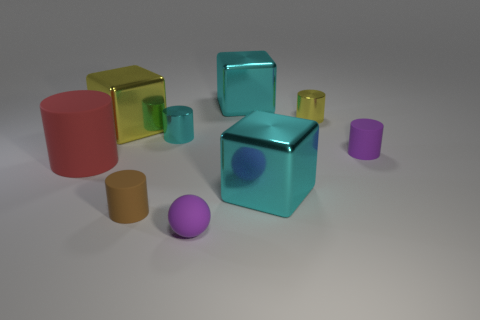Are the big yellow block and the tiny yellow cylinder made of the same material?
Your answer should be very brief. Yes. What number of things are large red things or tiny metallic cylinders?
Offer a terse response. 3. There is a yellow thing that is to the left of the matte sphere; what is its shape?
Keep it short and to the point. Cube. There is another cylinder that is the same material as the cyan cylinder; what color is it?
Your answer should be very brief. Yellow. There is a small cyan thing that is the same shape as the red thing; what is it made of?
Keep it short and to the point. Metal. The big red matte object has what shape?
Give a very brief answer. Cylinder. What is the small cylinder that is both to the right of the tiny purple sphere and to the left of the tiny purple rubber cylinder made of?
Your answer should be very brief. Metal. There is a tiny object that is made of the same material as the small cyan cylinder; what is its shape?
Offer a terse response. Cylinder. There is a cyan cylinder that is the same material as the large yellow cube; what is its size?
Provide a short and direct response. Small. There is a tiny object that is both behind the small purple matte cylinder and left of the tiny rubber sphere; what is its shape?
Your answer should be very brief. Cylinder. 